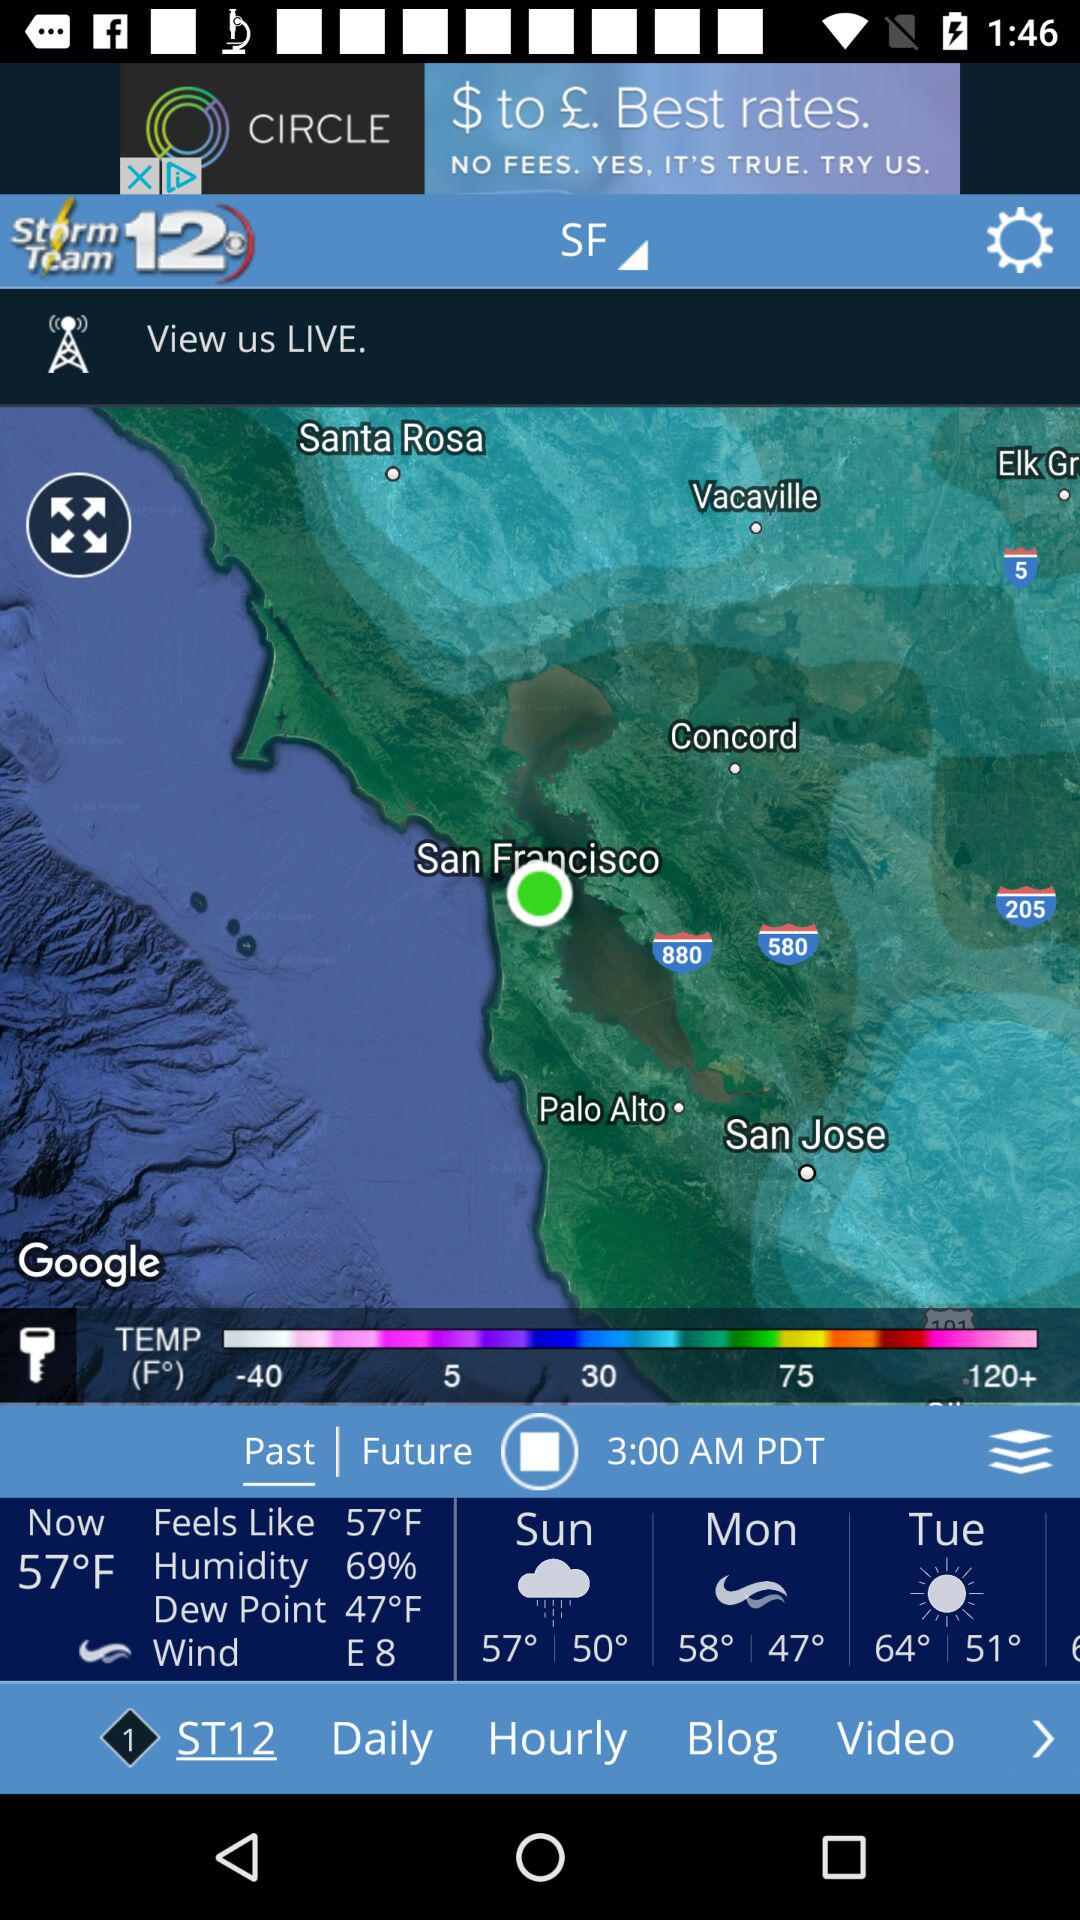How many degrees Fahrenheit is the current temperature?
Answer the question using a single word or phrase. 57°F 